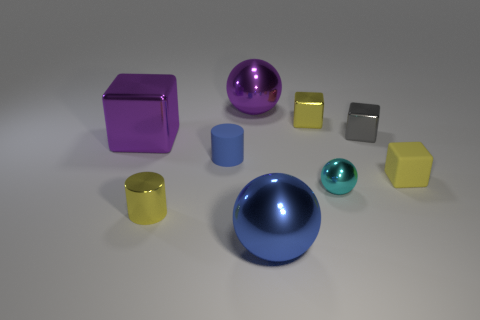Subtract 2 cylinders. How many cylinders are left? 0 Subtract all purple cubes. Subtract all tiny blue cylinders. How many objects are left? 7 Add 5 shiny balls. How many shiny balls are left? 8 Add 5 large green matte things. How many large green matte things exist? 5 Subtract all blue balls. How many balls are left? 2 Subtract all purple metal cubes. How many cubes are left? 3 Subtract 0 red spheres. How many objects are left? 9 Subtract all balls. How many objects are left? 6 Subtract all brown balls. Subtract all blue cubes. How many balls are left? 3 Subtract all purple cubes. How many green balls are left? 0 